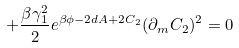<formula> <loc_0><loc_0><loc_500><loc_500>+ \frac { \beta \gamma _ { 1 } ^ { 2 } } { 2 } e ^ { \beta \phi - 2 d A + 2 C _ { 2 } } ( \partial _ { m } C _ { 2 } ) ^ { 2 } = 0</formula> 